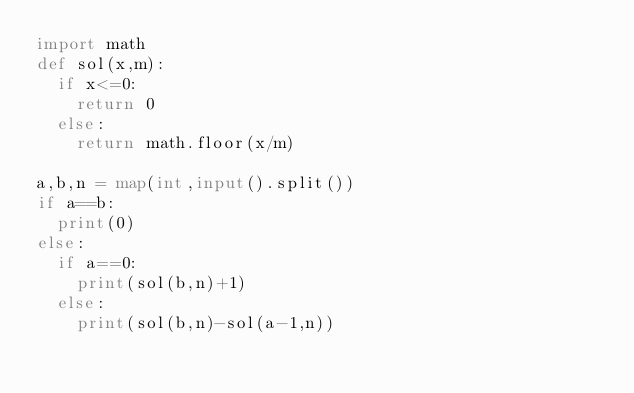Convert code to text. <code><loc_0><loc_0><loc_500><loc_500><_Python_>import math 
def sol(x,m):
	if x<=0:
		return 0
	else:
		return math.floor(x/m)

a,b,n = map(int,input().split())
if a==b:
	print(0)
else:
	if a==0:
		print(sol(b,n)+1)
	else:
		print(sol(b,n)-sol(a-1,n))</code> 